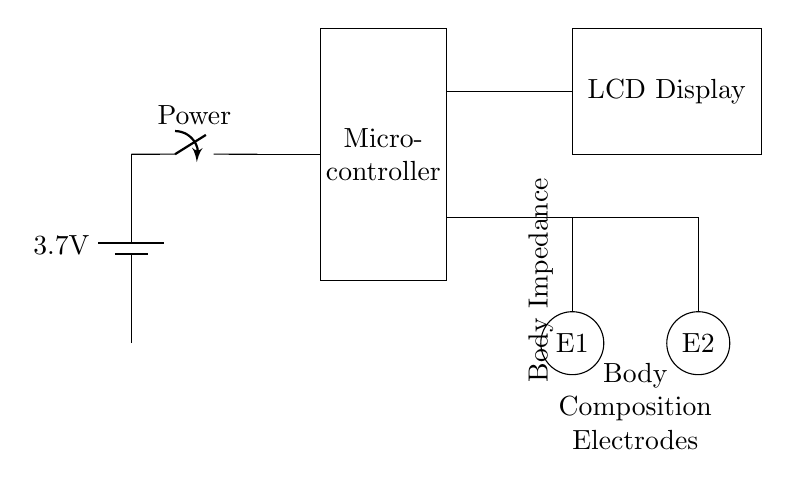What is the voltage rating of the battery? The battery is labeled as having a voltage of 3.7 volts, which is the potential difference supplied to the circuit components.
Answer: 3.7 volts What component is used to control power in the circuit? The circuit includes a switch labeled as "Power," which is used to control the flow of electricity from the battery to the rest of the circuit.
Answer: Switch What is the main function of the microcontroller? The microcontroller serves as the central processing unit, controlling the operation of the handheld body composition analyzer by processing data from the electrodes and sending output to the LCD display.
Answer: Central processing unit How many electrodes are present in the circuit? The circuit diagram shows two electrodes labeled E1 and E2, which are essential for measuring body impedance.
Answer: Two What is the purpose of the LCD display in this circuit? The LCD display receives output from the microcontroller and presents the body composition data to the user, allowing for visual feedback of the analysis results.
Answer: Display body composition data What type of current does this circuit likely operate on? Since the circuit is battery-operated and intended for handheld use, it likely operates on direct current. This is inferred from the presence of a battery as a power source.
Answer: Direct current What is the primary measurement taken by the circuit? The circuit is designed to measure body impedance, which is indicated by the label in the diagram that clarifies the connection to the electrodes. This measurement is crucial for calculating body composition metrics.
Answer: Body impedance 